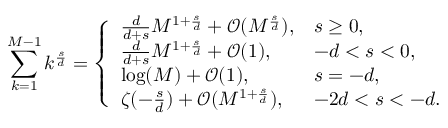Convert formula to latex. <formula><loc_0><loc_0><loc_500><loc_500>\sum _ { k = 1 } ^ { M - 1 } k ^ { \frac { s } { d } } = \left \{ \begin{array} { l l } { \frac { d } { d + s } M ^ { 1 + \frac { s } { d } } + \mathcal { O } ( M ^ { \frac { s } { d } } ) , } & { s \geq 0 , } \\ { \frac { d } { d + s } M ^ { 1 + \frac { s } { d } } + \mathcal { O } ( 1 ) , } & { - d < s < 0 , } \\ { \log ( M ) + \mathcal { O } ( 1 ) , } & { s = - d , } \\ { \zeta ( - \frac { s } { d } ) + \mathcal { O } ( M ^ { 1 + \frac { s } { d } } ) , } & { - 2 d < s < - d . } \end{array}</formula> 